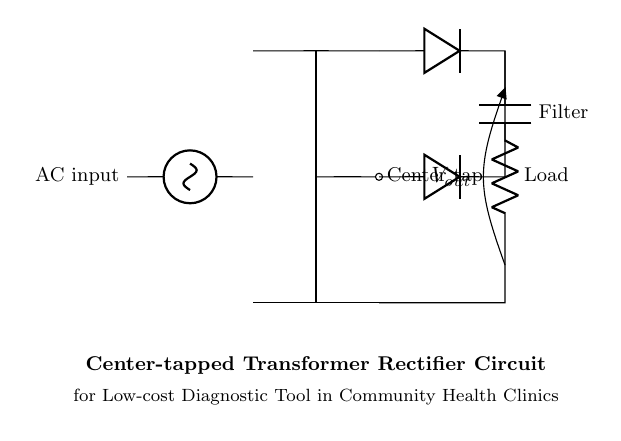What is the AC input type in this circuit? The circuit uses a sinusoidal voltage source as the AC input, indicated by the symbol for a sinusoidal voltage source in the diagram.
Answer: sinusoidal What are the two main components used to convert AC to DC? The circuit diagram shows diodes as the main components for converting AC to DC; they allow current to flow in one direction, effectively rectifying the AC signal.
Answer: diodes What is the purpose of the capacitor in the circuit? The capacitor acts as a filter; it smooths the output voltage by charging and discharging, thereby reducing fluctuations in the DC output.
Answer: filter How many diodes are present in this circuit? There are two diodes indicated in the circuit, both placed parallel to the load, which allows current to be rectified from both halves of the AC waveform.
Answer: two What is the load in this circuit? The load is represented by the resistor symbol with a label indicating load; it is the component that the DC output is driving in the circuit.
Answer: Load What does the center tap in the transformer indicate? The center tap provides a reference point for the circuit; it allows the transformer to deliver two equal voltage outputs, which are then used by the diodes for rectification.
Answer: center tap What is the output voltage noted as in the circuit? The output voltage is noted as V out in the circuit diagram, implying that it is the voltage measured across the load.
Answer: V out 